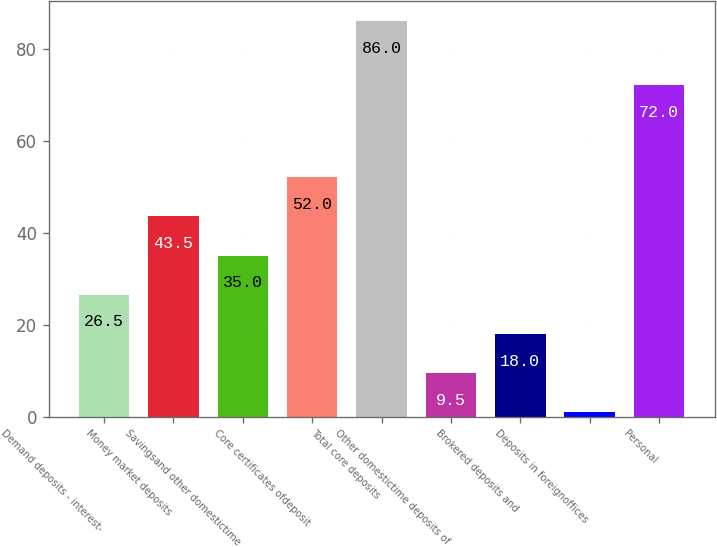Convert chart. <chart><loc_0><loc_0><loc_500><loc_500><bar_chart><fcel>Demand deposits - interest-<fcel>Money market deposits<fcel>Savingsand other domestictime<fcel>Core certificates ofdeposit<fcel>Total core deposits<fcel>Other domestictime deposits of<fcel>Brokered deposits and<fcel>Deposits in foreignoffices<fcel>Personal<nl><fcel>26.5<fcel>43.5<fcel>35<fcel>52<fcel>86<fcel>9.5<fcel>18<fcel>1<fcel>72<nl></chart> 